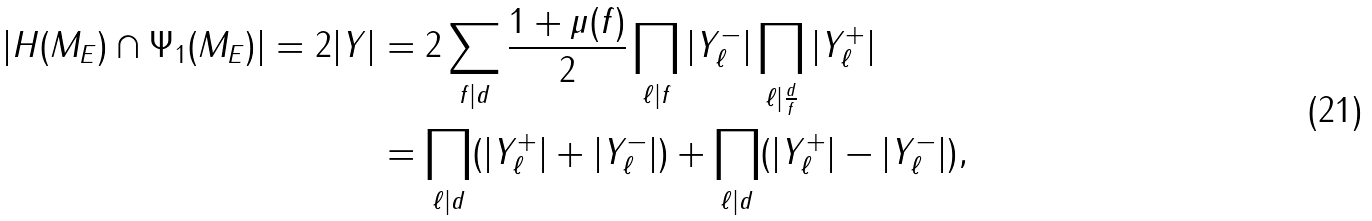Convert formula to latex. <formula><loc_0><loc_0><loc_500><loc_500>| H ( M _ { E } ) \cap \Psi _ { 1 } ( M _ { E } ) | = 2 | Y | & = 2 \sum _ { f | d } \frac { 1 + \mu ( f ) } { 2 } \prod _ { \ell | f } | Y _ { \ell } ^ { - } | \prod _ { \ell | \frac { d } { f } } | Y _ { \ell } ^ { + } | \\ & = \prod _ { \ell | d } ( | Y _ { \ell } ^ { + } | + | Y _ { \ell } ^ { - } | ) + \prod _ { \ell | d } ( | Y _ { \ell } ^ { + } | - | Y _ { \ell } ^ { - } | ) ,</formula> 